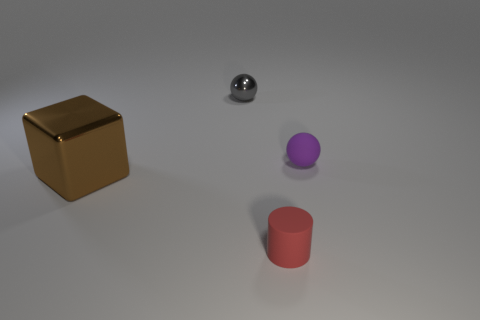What number of objects are either small purple balls or shiny things behind the large brown thing?
Offer a very short reply. 2. What number of other things are the same shape as the gray object?
Keep it short and to the point. 1. Do the small sphere that is right of the rubber cylinder and the red cylinder have the same material?
Your answer should be compact. Yes. How many things are tiny red rubber things or large green matte spheres?
Provide a short and direct response. 1. The purple matte object that is the same shape as the small gray object is what size?
Your response must be concise. Small. The metallic ball is what size?
Your answer should be very brief. Small. Are there more tiny matte cylinders behind the cube than big purple shiny cubes?
Provide a succinct answer. No. Is there any other thing that has the same material as the small red object?
Offer a very short reply. Yes. There is a tiny matte thing in front of the purple rubber sphere; is it the same color as the object that is on the left side of the tiny metal object?
Provide a succinct answer. No. The tiny ball that is behind the ball in front of the object that is behind the purple matte object is made of what material?
Keep it short and to the point. Metal. 